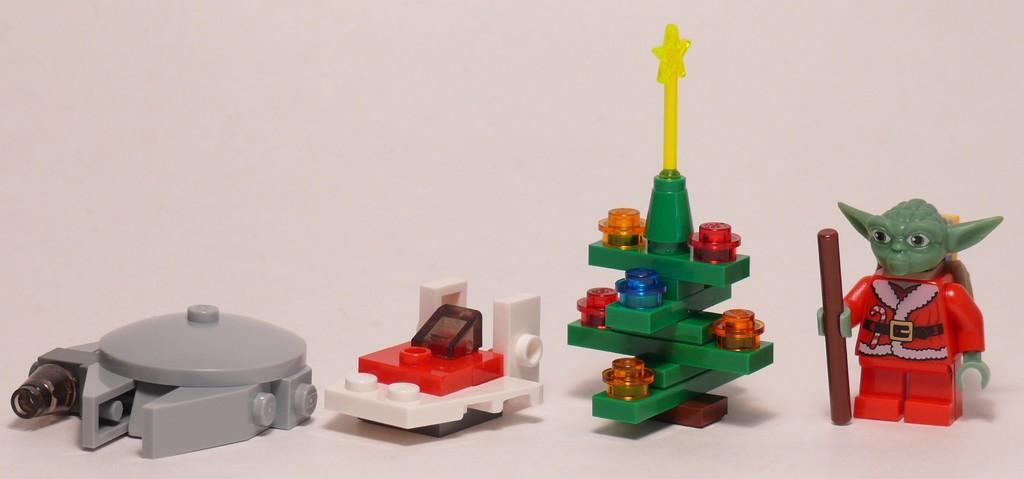What type of toys are in the image? There are lego toys in the image. What can be said about the appearance of the lego toys? The lego toys are colorful. On what surface are the lego toys placed? The lego toys are on a white surface. What is the color of the background in the image? The background of the image is white. How many prisoners are visible in the image? There are no prisoners present in the image; it features lego toys on a white surface with a white background. What type of adjustment is being made to the lego toys in the image? There is no adjustment being made to the lego toys in the image; they are stationary on the white surface. 